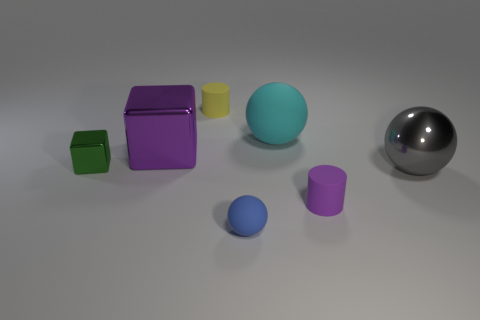Are there more cyan objects that are in front of the big rubber sphere than big green metallic spheres?
Your answer should be very brief. No. How many small objects are blue objects or purple blocks?
Keep it short and to the point. 1. How many blue matte things have the same shape as the cyan object?
Your answer should be very brief. 1. What material is the sphere that is in front of the matte cylinder to the right of the yellow rubber cylinder?
Offer a terse response. Rubber. How big is the purple object that is behind the gray thing?
Your answer should be very brief. Large. What number of blue objects are tiny rubber spheres or small metal cubes?
Provide a short and direct response. 1. Is there anything else that has the same material as the tiny blue ball?
Your answer should be very brief. Yes. What is the material of the gray object that is the same shape as the big cyan rubber thing?
Give a very brief answer. Metal. Is the number of gray shiny things that are on the left side of the gray metal object the same as the number of large red rubber balls?
Give a very brief answer. Yes. There is a sphere that is both to the left of the purple cylinder and behind the purple cylinder; how big is it?
Provide a succinct answer. Large. 